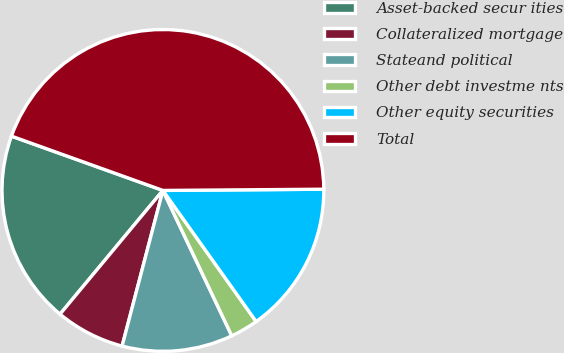<chart> <loc_0><loc_0><loc_500><loc_500><pie_chart><fcel>Asset-backed secur ities<fcel>Collateralized mortgage<fcel>Stateand political<fcel>Other debt investme nts<fcel>Other equity securities<fcel>Total<nl><fcel>19.44%<fcel>6.96%<fcel>11.12%<fcel>2.8%<fcel>15.28%<fcel>44.4%<nl></chart> 